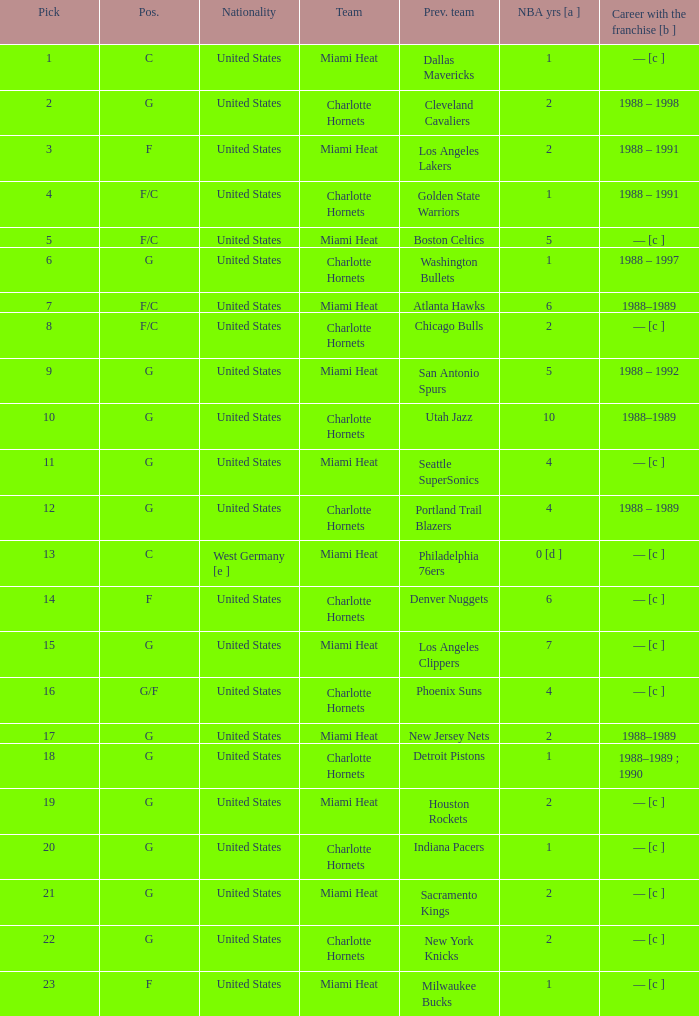What is the team of the player who was previously on the indiana pacers? Charlotte Hornets. 